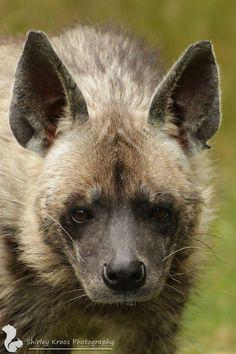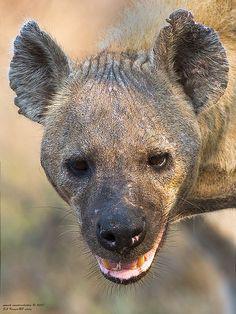The first image is the image on the left, the second image is the image on the right. Assess this claim about the two images: "Some teeth are visible in one of the images.". Correct or not? Answer yes or no. Yes. 